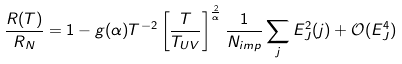Convert formula to latex. <formula><loc_0><loc_0><loc_500><loc_500>\frac { R ( T ) } { R _ { N } } = 1 - g ( \alpha ) T ^ { - 2 } \left [ \frac { T } { T _ { U V } } \right ] ^ { \frac { 2 } { \alpha } } \frac { 1 } { N _ { i m p } } \sum _ { j } E _ { J } ^ { 2 } ( j ) + \mathcal { O } ( E ^ { 4 } _ { J } )</formula> 